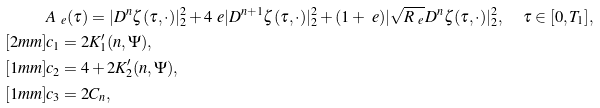Convert formula to latex. <formula><loc_0><loc_0><loc_500><loc_500>& A _ { \ e } ( \tau ) = | D ^ { n } \zeta ( \tau , \cdot ) | _ { 2 } ^ { 2 } + 4 \ e | D ^ { n + 1 } \zeta ( \tau , \cdot ) | _ { 2 } ^ { 2 } + ( 1 + \ e ) | \sqrt { R _ { \ e } } D ^ { n } \zeta ( \tau , \cdot ) | _ { 2 } ^ { 2 } , \quad \, \tau \in [ 0 , T _ { 1 } ] , \\ [ 2 m m ] & c _ { 1 } = 2 K _ { 1 } ^ { \prime } ( n , \Psi ) , \\ [ 1 m m ] & c _ { 2 } = 4 + 2 K _ { 2 } ^ { \prime } ( n , \Psi ) , \\ [ 1 m m ] & c _ { 3 } = 2 C _ { n } ,</formula> 